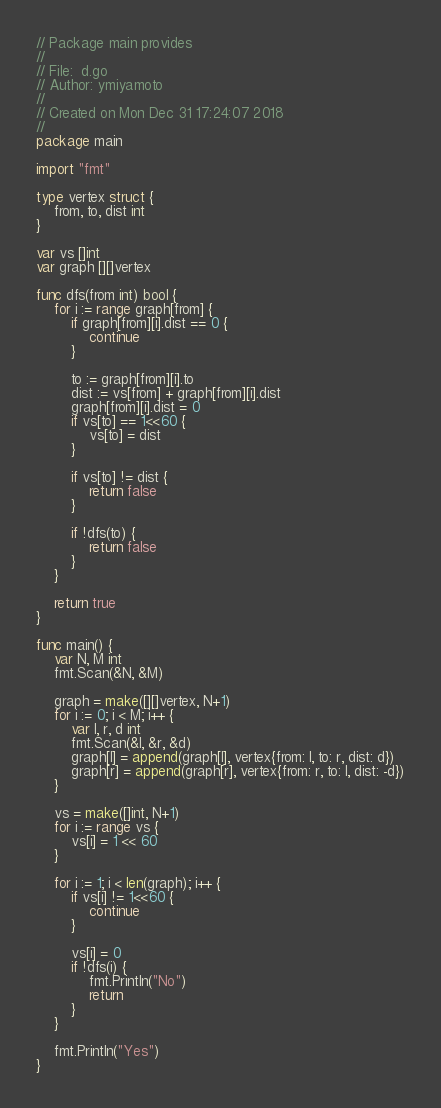Convert code to text. <code><loc_0><loc_0><loc_500><loc_500><_Go_>// Package main provides
//
// File:  d.go
// Author: ymiyamoto
//
// Created on Mon Dec 31 17:24:07 2018
//
package main

import "fmt"

type vertex struct {
	from, to, dist int
}

var vs []int
var graph [][]vertex

func dfs(from int) bool {
	for i := range graph[from] {
		if graph[from][i].dist == 0 {
			continue
		}

		to := graph[from][i].to
		dist := vs[from] + graph[from][i].dist
		graph[from][i].dist = 0
		if vs[to] == 1<<60 {
			vs[to] = dist
		}

		if vs[to] != dist {
			return false
		}

		if !dfs(to) {
			return false
		}
	}

	return true
}

func main() {
	var N, M int
	fmt.Scan(&N, &M)

	graph = make([][]vertex, N+1)
	for i := 0; i < M; i++ {
		var l, r, d int
		fmt.Scan(&l, &r, &d)
		graph[l] = append(graph[l], vertex{from: l, to: r, dist: d})
		graph[r] = append(graph[r], vertex{from: r, to: l, dist: -d})
	}

	vs = make([]int, N+1)
	for i := range vs {
		vs[i] = 1 << 60
	}

	for i := 1; i < len(graph); i++ {
		if vs[i] != 1<<60 {
			continue
		}

		vs[i] = 0
		if !dfs(i) {
			fmt.Println("No")
			return
		}
	}

	fmt.Println("Yes")
}
</code> 